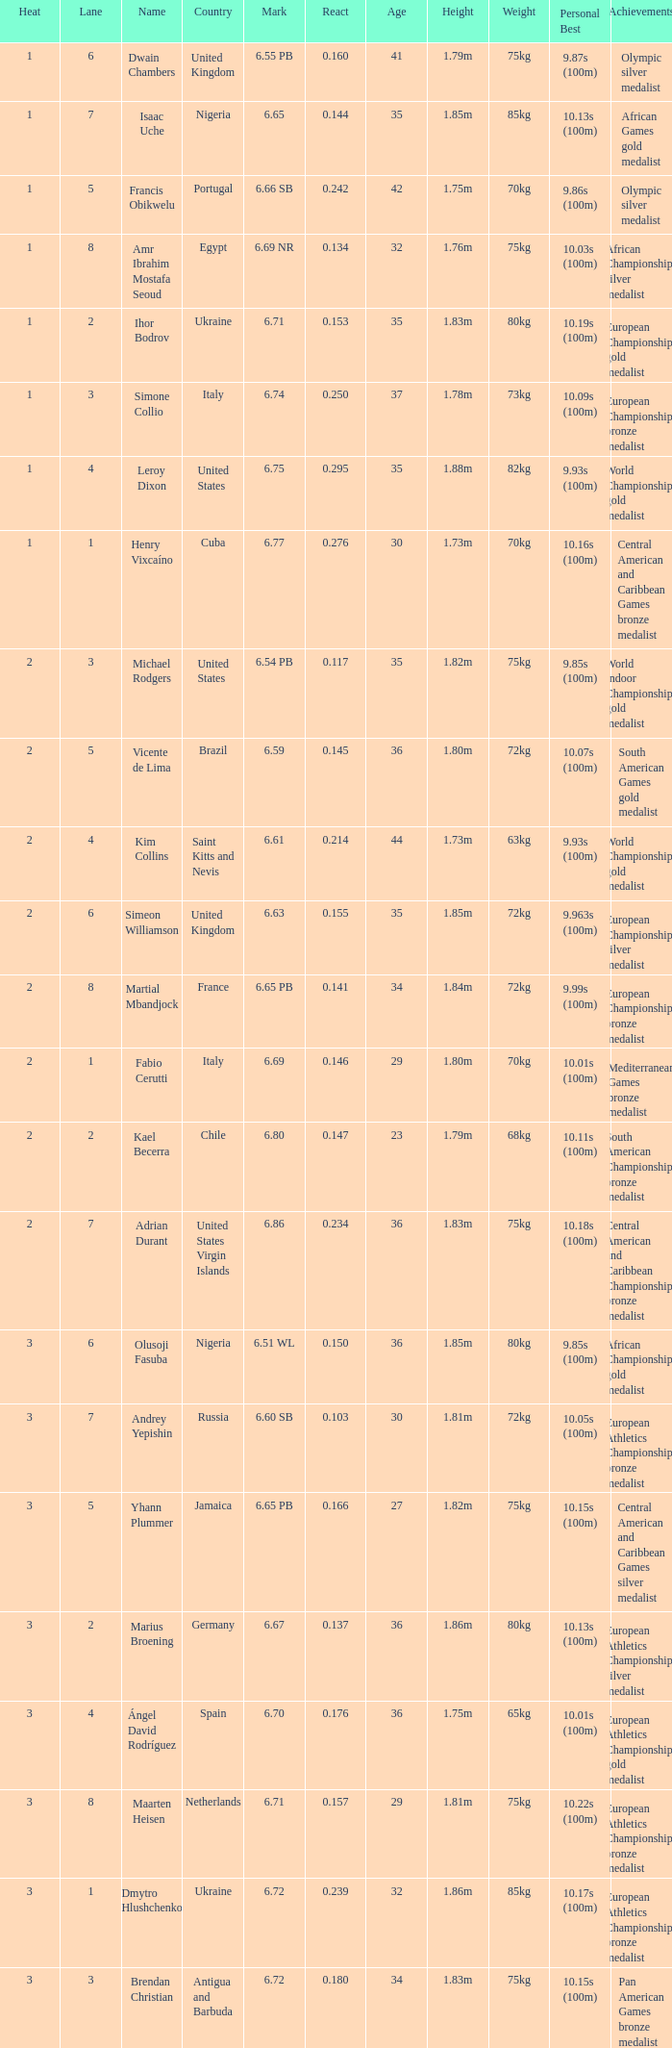What is the lowest Lane, when Country is France, and when React is less than 0.14100000000000001? 8.0. Write the full table. {'header': ['Heat', 'Lane', 'Name', 'Country', 'Mark', 'React', 'Age', 'Height', 'Weight', 'Personal Best', 'Achievements'], 'rows': [['1', '6', 'Dwain Chambers', 'United Kingdom', '6.55 PB', '0.160', '41', '1.79m', '75kg', '9.87s (100m)', 'Olympic silver medalist'], ['1', '7', 'Isaac Uche', 'Nigeria', '6.65', '0.144', '35', '1.85m', '85kg', '10.13s (100m)', 'African Games gold medalist'], ['1', '5', 'Francis Obikwelu', 'Portugal', '6.66 SB', '0.242', '42', '1.75m', '70kg', '9.86s (100m)', 'Olympic silver medalist'], ['1', '8', 'Amr Ibrahim Mostafa Seoud', 'Egypt', '6.69 NR', '0.134', '32', '1.76m', '75kg', '10.03s (100m)', 'African Championships silver medalist'], ['1', '2', 'Ihor Bodrov', 'Ukraine', '6.71', '0.153', '35', '1.83m', '80kg', '10.19s (100m)', 'European Championships gold medalist'], ['1', '3', 'Simone Collio', 'Italy', '6.74', '0.250', '37', '1.78m', '73kg', '10.09s (100m)', 'European Championships bronze medalist'], ['1', '4', 'Leroy Dixon', 'United States', '6.75', '0.295', '35', '1.88m', '82kg', '9.93s (100m)', 'World Championships gold medalist'], ['1', '1', 'Henry Vixcaíno', 'Cuba', '6.77', '0.276', '30', '1.73m', '70kg', '10.16s (100m)', 'Central American and Caribbean Games bronze medalist'], ['2', '3', 'Michael Rodgers', 'United States', '6.54 PB', '0.117', '35', '1.82m', '75kg', '9.85s (100m)', 'World Indoor Championships gold medalist'], ['2', '5', 'Vicente de Lima', 'Brazil', '6.59', '0.145', '36', '1.80m', '72kg', '10.07s (100m)', 'South American Games gold medalist'], ['2', '4', 'Kim Collins', 'Saint Kitts and Nevis', '6.61', '0.214', '44', '1.73m', '63kg', '9.93s (100m)', 'World Championships gold medalist'], ['2', '6', 'Simeon Williamson', 'United Kingdom', '6.63', '0.155', '35', '1.85m', '72kg', '9.963s (100m)', 'European Championships silver medalist'], ['2', '8', 'Martial Mbandjock', 'France', '6.65 PB', '0.141', '34', '1.84m', '72kg', '9.99s (100m)', 'European Championships bronze medalist'], ['2', '1', 'Fabio Cerutti', 'Italy', '6.69', '0.146', '29', '1.80m', '70kg', '10.01s (100m)', 'Mediterranean Games bronze medalist'], ['2', '2', 'Kael Becerra', 'Chile', '6.80', '0.147', '23', '1.79m', '68kg', '10.11s (100m)', 'South American Championships bronze medalist'], ['2', '7', 'Adrian Durant', 'United States Virgin Islands', '6.86', '0.234', '36', '1.83m', '75kg', '10.18s (100m)', 'Central American and Caribbean Championships bronze medalist'], ['3', '6', 'Olusoji Fasuba', 'Nigeria', '6.51 WL', '0.150', '36', '1.85m', '80kg', '9.85s (100m)', 'African Championships gold medalist'], ['3', '7', 'Andrey Yepishin', 'Russia', '6.60 SB', '0.103', '30', '1.81m', '72kg', '10.05s (100m)', 'European Athletics Championships bronze medalist'], ['3', '5', 'Yhann Plummer', 'Jamaica', '6.65 PB', '0.166', '27', '1.82m', '75kg', '10.15s (100m)', 'Central American and Caribbean Games silver medalist'], ['3', '2', 'Marius Broening', 'Germany', '6.67', '0.137', '36', '1.86m', '80kg', '10.13s (100m)', 'European Athletics Championships silver medalist'], ['3', '4', 'Ángel David Rodríguez', 'Spain', '6.70', '0.176', '36', '1.75m', '65kg', '10.01s (100m)', 'European Athletics Championships gold medalist'], ['3', '8', 'Maarten Heisen', 'Netherlands', '6.71', '0.157', '29', '1.81m', '75kg', '10.22s (100m)', 'European Athletics Championships bronze medalist'], ['3', '1', 'Dmytro Hlushchenko', 'Ukraine', '6.72', '0.239', '32', '1.86m', '85kg', '10.17s (100m)', 'European Athletics Championships bronze medalist'], ['3', '3', 'Brendan Christian', 'Antigua and Barbuda', '6.72', '0.180', '34', '1.83m', '75kg', '10.15s (100m)', 'Pan American Games bronze medalist']]} 